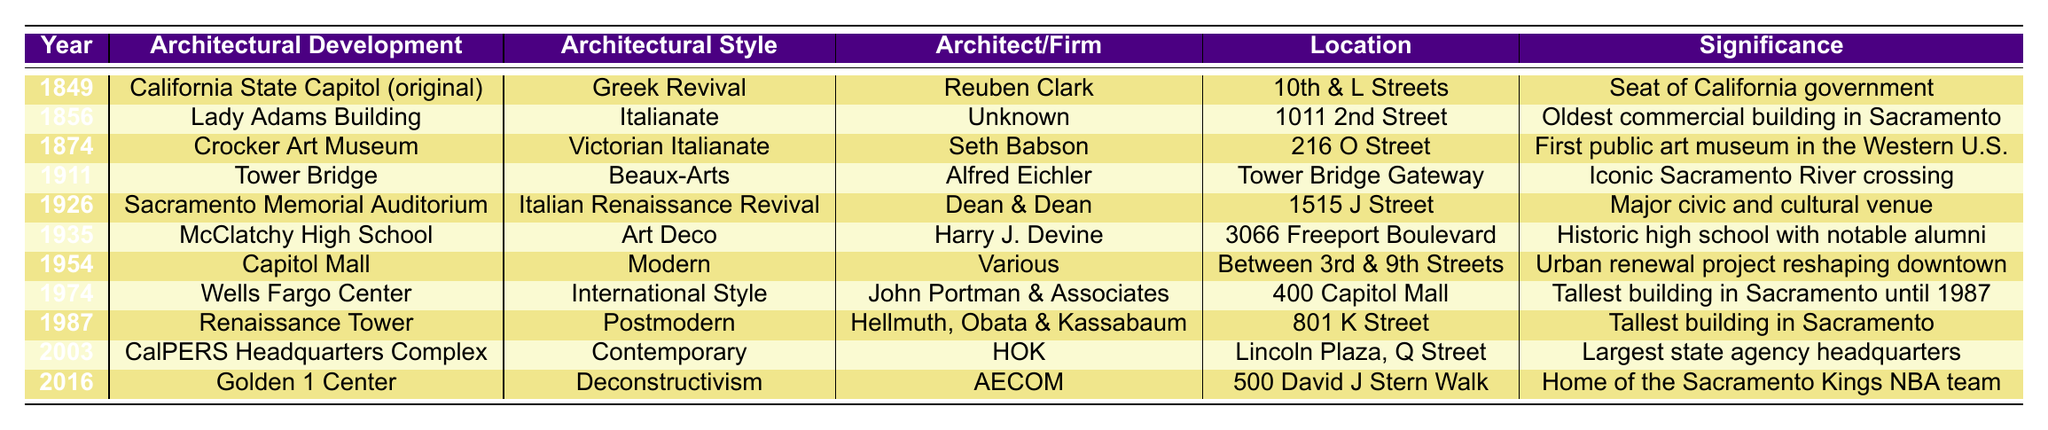What is the architectural style of the Golden 1 Center? The table lists the architectural style of the Golden 1 Center under the "Architectural Style" column, which indicates it is "Deconstructivism."
Answer: Deconstructivism Which architectural development was completed in 1874? By looking at the "Year" column, I can find that the architectural development listed for 1874 is the "Crocker Art Museum."
Answer: Crocker Art Museum How many architectural developments listed are designed in the Italian style? The table shows two developments that include the term "Italian" in their architectural style: the Lady Adams Building (1856) and Sacramento Memorial Auditorium (1926). Therefore, the count is 2.
Answer: 2 Which building is the tallest building in Sacramento and when was it completed? Referring to the "Significance" column, the "Renaissance Tower," completed in 1987, is noted as the tallest building in Sacramento.
Answer: Renaissance Tower, 1987 Is the California State Capitol the most significant building in the table? The significance of the California State Capitol is listed as the "Seat of California government," which would make it quite significant but whether it's the "most" significant is subjective. However, it is definitely one of the most important buildings in the table.
Answer: Yes What is the difference in years between the completion of the Capitol Mall and Wells Fargo Center? The Capitol Mall was completed in 1954 and the Wells Fargo Center in 1974. The difference is 1974 - 1954 = 20 years.
Answer: 20 years List all the buildings designed by the firm AECOM. Looking at the "Architect/Firm" column, AECOM is associated only with the "Golden 1 Center," which was completed in 2016.
Answer: Golden 1 Center Which architectural style was used for the Crocker Art Museum? The "Architectural Style" column indicates that the Crocker Art Museum follows the Victorian Italianate style.
Answer: Victorian Italianate How many architectural developments were completed in the 20th century? The 20th-century developments listed are the Tower Bridge (1911), Sacramento Memorial Auditorium (1926), McClatchy High School (1935), Capitol Mall (1954), Wells Fargo Center (1974), Renaissance Tower (1987), CalPERS Headquarters Complex (2003), totaling 7 developments.
Answer: 7 What architectural style is associated with the Lady Adams Building? The "Architectural Style" column shows that the Lady Adams Building is designed in the Italianate style.
Answer: Italianate 